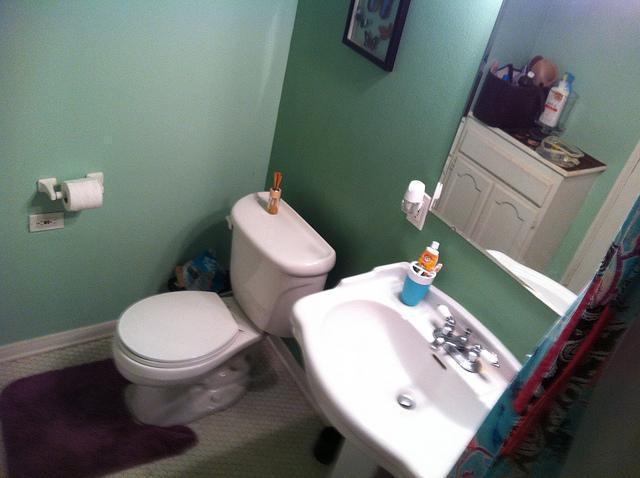What is likely in the large bottle in the reflection?
Choose the right answer from the provided options to respond to the question.
Options: Conditioner, sunscreen, shampoo, lotion. Lotion. 